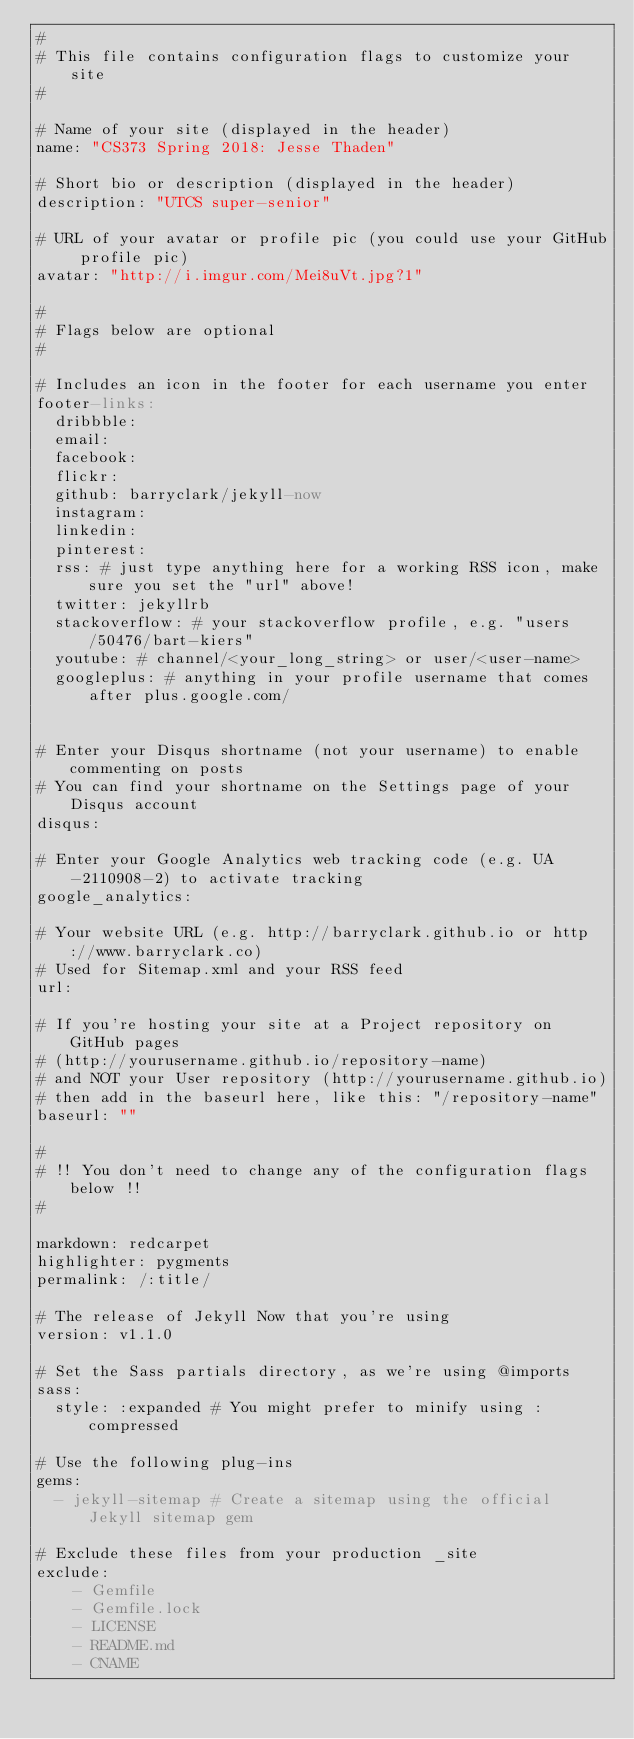Convert code to text. <code><loc_0><loc_0><loc_500><loc_500><_YAML_>#
# This file contains configuration flags to customize your site
#

# Name of your site (displayed in the header)
name: "CS373 Spring 2018: Jesse Thaden"

# Short bio or description (displayed in the header)
description: "UTCS super-senior"

# URL of your avatar or profile pic (you could use your GitHub profile pic)
avatar: "http://i.imgur.com/Mei8uVt.jpg?1"

#
# Flags below are optional
#

# Includes an icon in the footer for each username you enter
footer-links:
  dribbble:
  email:
  facebook:
  flickr:
  github: barryclark/jekyll-now
  instagram:
  linkedin:
  pinterest:
  rss: # just type anything here for a working RSS icon, make sure you set the "url" above!
  twitter: jekyllrb
  stackoverflow: # your stackoverflow profile, e.g. "users/50476/bart-kiers"
  youtube: # channel/<your_long_string> or user/<user-name>
  googleplus: # anything in your profile username that comes after plus.google.com/


# Enter your Disqus shortname (not your username) to enable commenting on posts
# You can find your shortname on the Settings page of your Disqus account
disqus:

# Enter your Google Analytics web tracking code (e.g. UA-2110908-2) to activate tracking
google_analytics:

# Your website URL (e.g. http://barryclark.github.io or http://www.barryclark.co)
# Used for Sitemap.xml and your RSS feed
url:

# If you're hosting your site at a Project repository on GitHub pages
# (http://yourusername.github.io/repository-name)
# and NOT your User repository (http://yourusername.github.io)
# then add in the baseurl here, like this: "/repository-name"
baseurl: ""

#
# !! You don't need to change any of the configuration flags below !!
#

markdown: redcarpet
highlighter: pygments
permalink: /:title/

# The release of Jekyll Now that you're using
version: v1.1.0

# Set the Sass partials directory, as we're using @imports
sass:
  style: :expanded # You might prefer to minify using :compressed

# Use the following plug-ins
gems:
  - jekyll-sitemap # Create a sitemap using the official Jekyll sitemap gem

# Exclude these files from your production _site
exclude:
    - Gemfile
    - Gemfile.lock
    - LICENSE
    - README.md
    - CNAME
</code> 